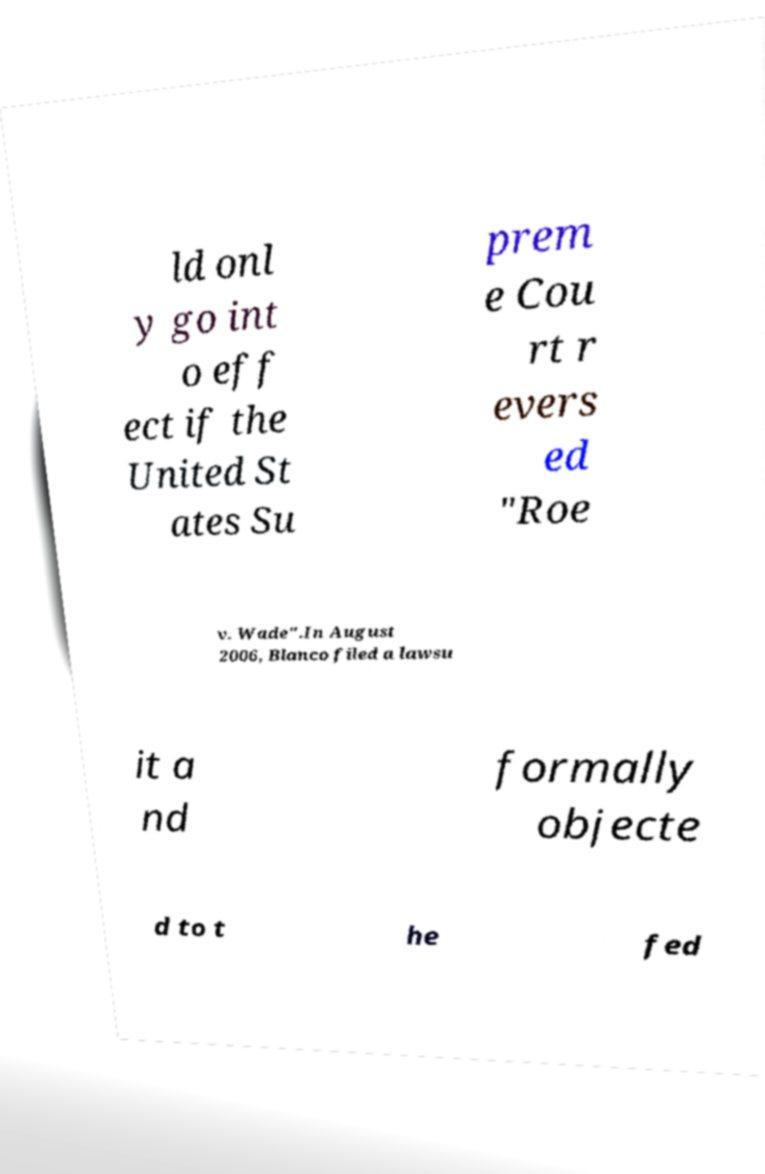Could you assist in decoding the text presented in this image and type it out clearly? ld onl y go int o eff ect if the United St ates Su prem e Cou rt r evers ed "Roe v. Wade".In August 2006, Blanco filed a lawsu it a nd formally objecte d to t he fed 